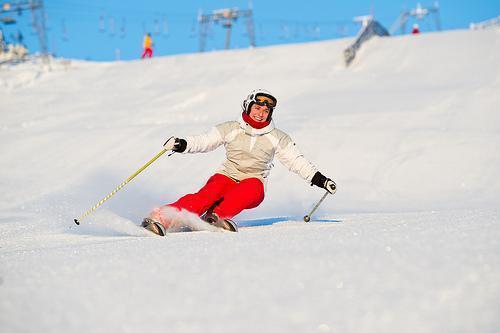How many skiers are there?
Give a very brief answer. 1. 